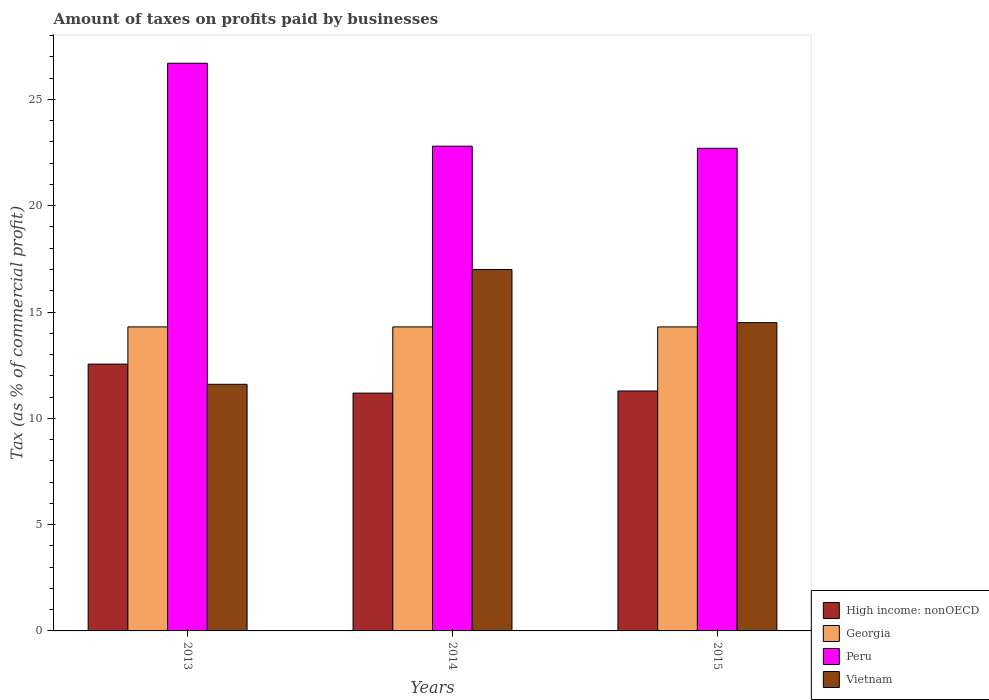How many different coloured bars are there?
Ensure brevity in your answer.  4. Are the number of bars on each tick of the X-axis equal?
Make the answer very short. Yes. How many bars are there on the 2nd tick from the left?
Offer a very short reply. 4. What is the percentage of taxes paid by businesses in High income: nonOECD in 2015?
Provide a succinct answer. 11.29. Across all years, what is the maximum percentage of taxes paid by businesses in Peru?
Your response must be concise. 26.7. In which year was the percentage of taxes paid by businesses in Vietnam minimum?
Your response must be concise. 2013. What is the total percentage of taxes paid by businesses in Peru in the graph?
Offer a very short reply. 72.2. What is the difference between the percentage of taxes paid by businesses in High income: nonOECD in 2013 and that in 2015?
Make the answer very short. 1.26. What is the difference between the percentage of taxes paid by businesses in Georgia in 2014 and the percentage of taxes paid by businesses in Vietnam in 2013?
Provide a short and direct response. 2.7. What is the average percentage of taxes paid by businesses in Vietnam per year?
Your answer should be very brief. 14.37. In the year 2013, what is the difference between the percentage of taxes paid by businesses in High income: nonOECD and percentage of taxes paid by businesses in Peru?
Your answer should be compact. -14.15. In how many years, is the percentage of taxes paid by businesses in Georgia greater than 15 %?
Your response must be concise. 0. What is the ratio of the percentage of taxes paid by businesses in Georgia in 2013 to that in 2015?
Your answer should be very brief. 1. What is the difference between the highest and the second highest percentage of taxes paid by businesses in High income: nonOECD?
Offer a terse response. 1.26. What is the difference between the highest and the lowest percentage of taxes paid by businesses in Vietnam?
Provide a succinct answer. 5.4. Are all the bars in the graph horizontal?
Make the answer very short. No. What is the difference between two consecutive major ticks on the Y-axis?
Make the answer very short. 5. Are the values on the major ticks of Y-axis written in scientific E-notation?
Your answer should be compact. No. Does the graph contain grids?
Provide a short and direct response. No. Where does the legend appear in the graph?
Your answer should be compact. Bottom right. How many legend labels are there?
Your answer should be compact. 4. How are the legend labels stacked?
Make the answer very short. Vertical. What is the title of the graph?
Offer a terse response. Amount of taxes on profits paid by businesses. What is the label or title of the X-axis?
Offer a very short reply. Years. What is the label or title of the Y-axis?
Offer a very short reply. Tax (as % of commercial profit). What is the Tax (as % of commercial profit) in High income: nonOECD in 2013?
Offer a terse response. 12.55. What is the Tax (as % of commercial profit) of Georgia in 2013?
Ensure brevity in your answer.  14.3. What is the Tax (as % of commercial profit) of Peru in 2013?
Offer a very short reply. 26.7. What is the Tax (as % of commercial profit) of Vietnam in 2013?
Keep it short and to the point. 11.6. What is the Tax (as % of commercial profit) in High income: nonOECD in 2014?
Your answer should be compact. 11.19. What is the Tax (as % of commercial profit) of Georgia in 2014?
Ensure brevity in your answer.  14.3. What is the Tax (as % of commercial profit) in Peru in 2014?
Your response must be concise. 22.8. What is the Tax (as % of commercial profit) of Vietnam in 2014?
Offer a terse response. 17. What is the Tax (as % of commercial profit) of High income: nonOECD in 2015?
Provide a succinct answer. 11.29. What is the Tax (as % of commercial profit) of Georgia in 2015?
Your answer should be very brief. 14.3. What is the Tax (as % of commercial profit) of Peru in 2015?
Your answer should be very brief. 22.7. Across all years, what is the maximum Tax (as % of commercial profit) of High income: nonOECD?
Ensure brevity in your answer.  12.55. Across all years, what is the maximum Tax (as % of commercial profit) of Georgia?
Provide a succinct answer. 14.3. Across all years, what is the maximum Tax (as % of commercial profit) in Peru?
Your answer should be very brief. 26.7. Across all years, what is the maximum Tax (as % of commercial profit) in Vietnam?
Give a very brief answer. 17. Across all years, what is the minimum Tax (as % of commercial profit) of High income: nonOECD?
Your answer should be very brief. 11.19. Across all years, what is the minimum Tax (as % of commercial profit) in Peru?
Make the answer very short. 22.7. Across all years, what is the minimum Tax (as % of commercial profit) in Vietnam?
Ensure brevity in your answer.  11.6. What is the total Tax (as % of commercial profit) in High income: nonOECD in the graph?
Ensure brevity in your answer.  35.02. What is the total Tax (as % of commercial profit) in Georgia in the graph?
Make the answer very short. 42.9. What is the total Tax (as % of commercial profit) of Peru in the graph?
Your response must be concise. 72.2. What is the total Tax (as % of commercial profit) in Vietnam in the graph?
Offer a terse response. 43.1. What is the difference between the Tax (as % of commercial profit) in High income: nonOECD in 2013 and that in 2014?
Your response must be concise. 1.36. What is the difference between the Tax (as % of commercial profit) in Georgia in 2013 and that in 2014?
Your answer should be compact. 0. What is the difference between the Tax (as % of commercial profit) of Peru in 2013 and that in 2014?
Your answer should be very brief. 3.9. What is the difference between the Tax (as % of commercial profit) of Vietnam in 2013 and that in 2014?
Offer a very short reply. -5.4. What is the difference between the Tax (as % of commercial profit) in High income: nonOECD in 2013 and that in 2015?
Make the answer very short. 1.26. What is the difference between the Tax (as % of commercial profit) of Georgia in 2013 and that in 2015?
Provide a succinct answer. 0. What is the difference between the Tax (as % of commercial profit) of Peru in 2013 and that in 2015?
Offer a terse response. 4. What is the difference between the Tax (as % of commercial profit) of Vietnam in 2013 and that in 2015?
Offer a very short reply. -2.9. What is the difference between the Tax (as % of commercial profit) of High income: nonOECD in 2014 and that in 2015?
Offer a very short reply. -0.1. What is the difference between the Tax (as % of commercial profit) of High income: nonOECD in 2013 and the Tax (as % of commercial profit) of Georgia in 2014?
Make the answer very short. -1.75. What is the difference between the Tax (as % of commercial profit) in High income: nonOECD in 2013 and the Tax (as % of commercial profit) in Peru in 2014?
Your response must be concise. -10.25. What is the difference between the Tax (as % of commercial profit) in High income: nonOECD in 2013 and the Tax (as % of commercial profit) in Vietnam in 2014?
Give a very brief answer. -4.45. What is the difference between the Tax (as % of commercial profit) in Georgia in 2013 and the Tax (as % of commercial profit) in Peru in 2014?
Offer a very short reply. -8.5. What is the difference between the Tax (as % of commercial profit) of High income: nonOECD in 2013 and the Tax (as % of commercial profit) of Georgia in 2015?
Your response must be concise. -1.75. What is the difference between the Tax (as % of commercial profit) in High income: nonOECD in 2013 and the Tax (as % of commercial profit) in Peru in 2015?
Make the answer very short. -10.15. What is the difference between the Tax (as % of commercial profit) in High income: nonOECD in 2013 and the Tax (as % of commercial profit) in Vietnam in 2015?
Ensure brevity in your answer.  -1.95. What is the difference between the Tax (as % of commercial profit) of Georgia in 2013 and the Tax (as % of commercial profit) of Peru in 2015?
Provide a short and direct response. -8.4. What is the difference between the Tax (as % of commercial profit) in Georgia in 2013 and the Tax (as % of commercial profit) in Vietnam in 2015?
Your answer should be compact. -0.2. What is the difference between the Tax (as % of commercial profit) of Peru in 2013 and the Tax (as % of commercial profit) of Vietnam in 2015?
Keep it short and to the point. 12.2. What is the difference between the Tax (as % of commercial profit) in High income: nonOECD in 2014 and the Tax (as % of commercial profit) in Georgia in 2015?
Keep it short and to the point. -3.11. What is the difference between the Tax (as % of commercial profit) in High income: nonOECD in 2014 and the Tax (as % of commercial profit) in Peru in 2015?
Your response must be concise. -11.51. What is the difference between the Tax (as % of commercial profit) of High income: nonOECD in 2014 and the Tax (as % of commercial profit) of Vietnam in 2015?
Provide a succinct answer. -3.31. What is the difference between the Tax (as % of commercial profit) in Georgia in 2014 and the Tax (as % of commercial profit) in Peru in 2015?
Provide a succinct answer. -8.4. What is the difference between the Tax (as % of commercial profit) in Georgia in 2014 and the Tax (as % of commercial profit) in Vietnam in 2015?
Your answer should be compact. -0.2. What is the difference between the Tax (as % of commercial profit) of Peru in 2014 and the Tax (as % of commercial profit) of Vietnam in 2015?
Your answer should be compact. 8.3. What is the average Tax (as % of commercial profit) of High income: nonOECD per year?
Make the answer very short. 11.67. What is the average Tax (as % of commercial profit) in Peru per year?
Ensure brevity in your answer.  24.07. What is the average Tax (as % of commercial profit) of Vietnam per year?
Offer a very short reply. 14.37. In the year 2013, what is the difference between the Tax (as % of commercial profit) in High income: nonOECD and Tax (as % of commercial profit) in Georgia?
Offer a very short reply. -1.75. In the year 2013, what is the difference between the Tax (as % of commercial profit) of High income: nonOECD and Tax (as % of commercial profit) of Peru?
Provide a short and direct response. -14.15. In the year 2013, what is the difference between the Tax (as % of commercial profit) in High income: nonOECD and Tax (as % of commercial profit) in Vietnam?
Offer a terse response. 0.95. In the year 2013, what is the difference between the Tax (as % of commercial profit) in Georgia and Tax (as % of commercial profit) in Vietnam?
Provide a short and direct response. 2.7. In the year 2014, what is the difference between the Tax (as % of commercial profit) of High income: nonOECD and Tax (as % of commercial profit) of Georgia?
Offer a very short reply. -3.11. In the year 2014, what is the difference between the Tax (as % of commercial profit) of High income: nonOECD and Tax (as % of commercial profit) of Peru?
Give a very brief answer. -11.61. In the year 2014, what is the difference between the Tax (as % of commercial profit) in High income: nonOECD and Tax (as % of commercial profit) in Vietnam?
Keep it short and to the point. -5.81. In the year 2015, what is the difference between the Tax (as % of commercial profit) of High income: nonOECD and Tax (as % of commercial profit) of Georgia?
Provide a short and direct response. -3.01. In the year 2015, what is the difference between the Tax (as % of commercial profit) of High income: nonOECD and Tax (as % of commercial profit) of Peru?
Your answer should be very brief. -11.41. In the year 2015, what is the difference between the Tax (as % of commercial profit) of High income: nonOECD and Tax (as % of commercial profit) of Vietnam?
Make the answer very short. -3.21. In the year 2015, what is the difference between the Tax (as % of commercial profit) in Georgia and Tax (as % of commercial profit) in Vietnam?
Offer a terse response. -0.2. What is the ratio of the Tax (as % of commercial profit) of High income: nonOECD in 2013 to that in 2014?
Offer a very short reply. 1.12. What is the ratio of the Tax (as % of commercial profit) of Peru in 2013 to that in 2014?
Offer a terse response. 1.17. What is the ratio of the Tax (as % of commercial profit) in Vietnam in 2013 to that in 2014?
Ensure brevity in your answer.  0.68. What is the ratio of the Tax (as % of commercial profit) in High income: nonOECD in 2013 to that in 2015?
Your answer should be compact. 1.11. What is the ratio of the Tax (as % of commercial profit) in Georgia in 2013 to that in 2015?
Your response must be concise. 1. What is the ratio of the Tax (as % of commercial profit) in Peru in 2013 to that in 2015?
Make the answer very short. 1.18. What is the ratio of the Tax (as % of commercial profit) in Vietnam in 2013 to that in 2015?
Ensure brevity in your answer.  0.8. What is the ratio of the Tax (as % of commercial profit) of High income: nonOECD in 2014 to that in 2015?
Make the answer very short. 0.99. What is the ratio of the Tax (as % of commercial profit) in Vietnam in 2014 to that in 2015?
Offer a very short reply. 1.17. What is the difference between the highest and the second highest Tax (as % of commercial profit) in High income: nonOECD?
Offer a terse response. 1.26. What is the difference between the highest and the second highest Tax (as % of commercial profit) in Peru?
Offer a very short reply. 3.9. What is the difference between the highest and the lowest Tax (as % of commercial profit) in High income: nonOECD?
Make the answer very short. 1.36. What is the difference between the highest and the lowest Tax (as % of commercial profit) in Georgia?
Keep it short and to the point. 0. What is the difference between the highest and the lowest Tax (as % of commercial profit) of Vietnam?
Provide a succinct answer. 5.4. 